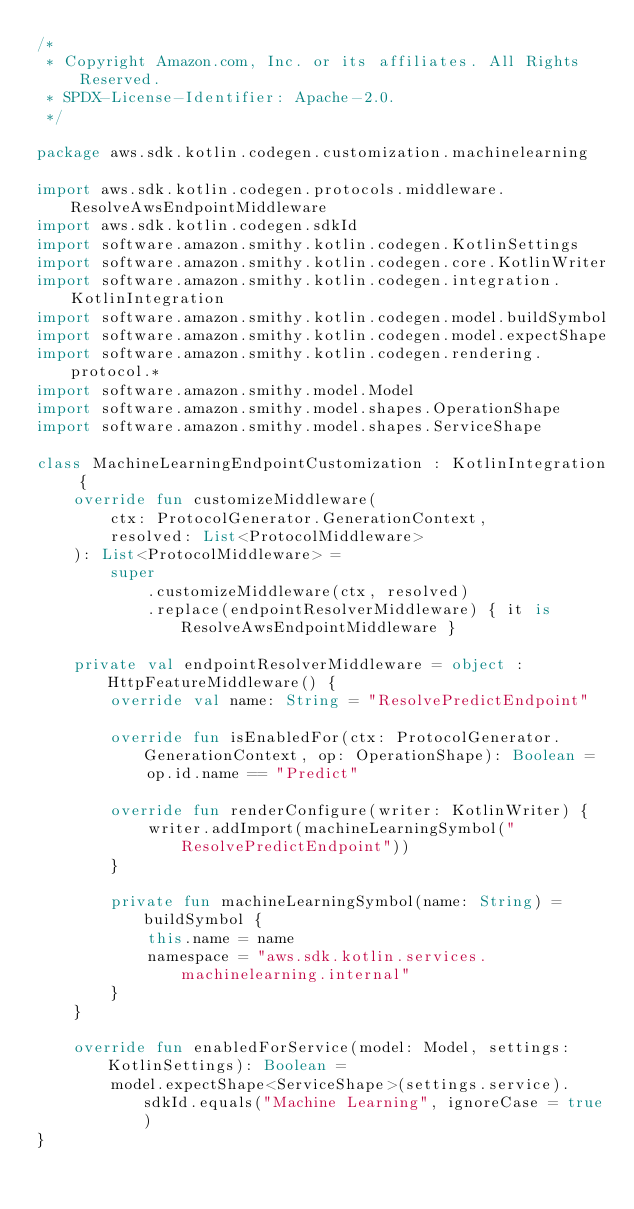Convert code to text. <code><loc_0><loc_0><loc_500><loc_500><_Kotlin_>/*
 * Copyright Amazon.com, Inc. or its affiliates. All Rights Reserved.
 * SPDX-License-Identifier: Apache-2.0.
 */

package aws.sdk.kotlin.codegen.customization.machinelearning

import aws.sdk.kotlin.codegen.protocols.middleware.ResolveAwsEndpointMiddleware
import aws.sdk.kotlin.codegen.sdkId
import software.amazon.smithy.kotlin.codegen.KotlinSettings
import software.amazon.smithy.kotlin.codegen.core.KotlinWriter
import software.amazon.smithy.kotlin.codegen.integration.KotlinIntegration
import software.amazon.smithy.kotlin.codegen.model.buildSymbol
import software.amazon.smithy.kotlin.codegen.model.expectShape
import software.amazon.smithy.kotlin.codegen.rendering.protocol.*
import software.amazon.smithy.model.Model
import software.amazon.smithy.model.shapes.OperationShape
import software.amazon.smithy.model.shapes.ServiceShape

class MachineLearningEndpointCustomization : KotlinIntegration {
    override fun customizeMiddleware(
        ctx: ProtocolGenerator.GenerationContext,
        resolved: List<ProtocolMiddleware>
    ): List<ProtocolMiddleware> =
        super
            .customizeMiddleware(ctx, resolved)
            .replace(endpointResolverMiddleware) { it is ResolveAwsEndpointMiddleware }

    private val endpointResolverMiddleware = object : HttpFeatureMiddleware() {
        override val name: String = "ResolvePredictEndpoint"

        override fun isEnabledFor(ctx: ProtocolGenerator.GenerationContext, op: OperationShape): Boolean =
            op.id.name == "Predict"

        override fun renderConfigure(writer: KotlinWriter) {
            writer.addImport(machineLearningSymbol("ResolvePredictEndpoint"))
        }

        private fun machineLearningSymbol(name: String) = buildSymbol {
            this.name = name
            namespace = "aws.sdk.kotlin.services.machinelearning.internal"
        }
    }

    override fun enabledForService(model: Model, settings: KotlinSettings): Boolean =
        model.expectShape<ServiceShape>(settings.service).sdkId.equals("Machine Learning", ignoreCase = true)
}
</code> 